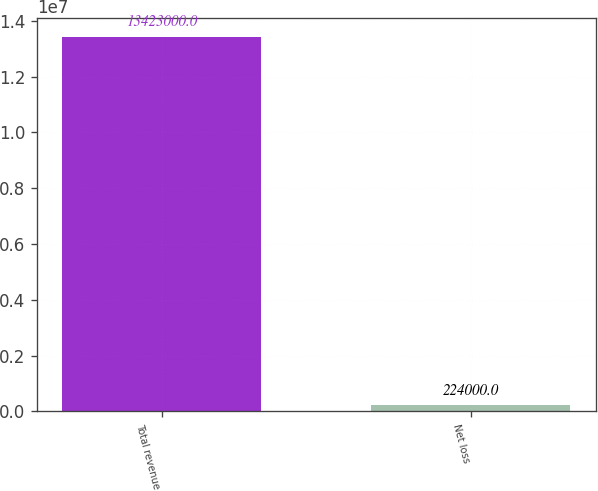Convert chart to OTSL. <chart><loc_0><loc_0><loc_500><loc_500><bar_chart><fcel>Total revenue<fcel>Net loss<nl><fcel>1.3423e+07<fcel>224000<nl></chart> 